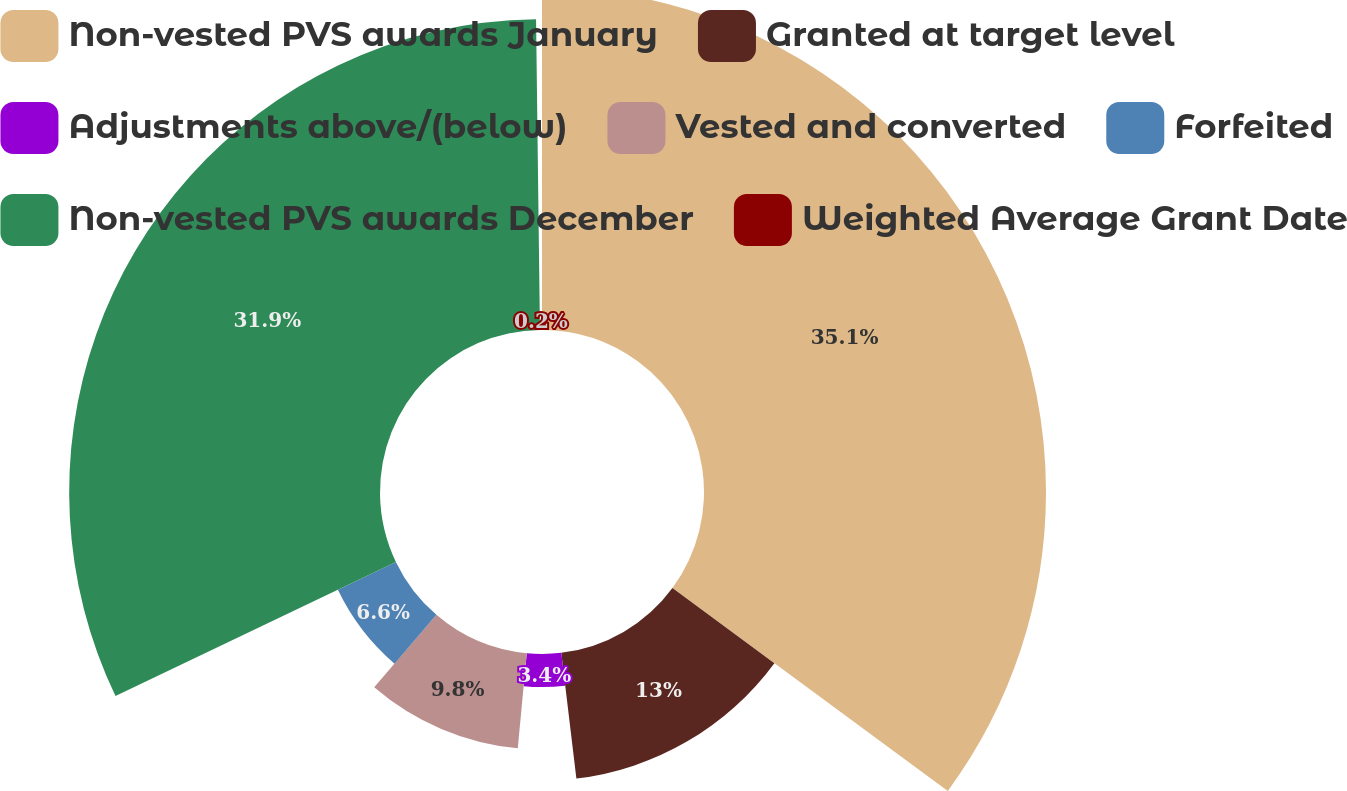<chart> <loc_0><loc_0><loc_500><loc_500><pie_chart><fcel>Non-vested PVS awards January<fcel>Granted at target level<fcel>Adjustments above/(below)<fcel>Vested and converted<fcel>Forfeited<fcel>Non-vested PVS awards December<fcel>Weighted Average Grant Date<nl><fcel>35.11%<fcel>13.0%<fcel>3.4%<fcel>9.8%<fcel>6.6%<fcel>31.91%<fcel>0.2%<nl></chart> 